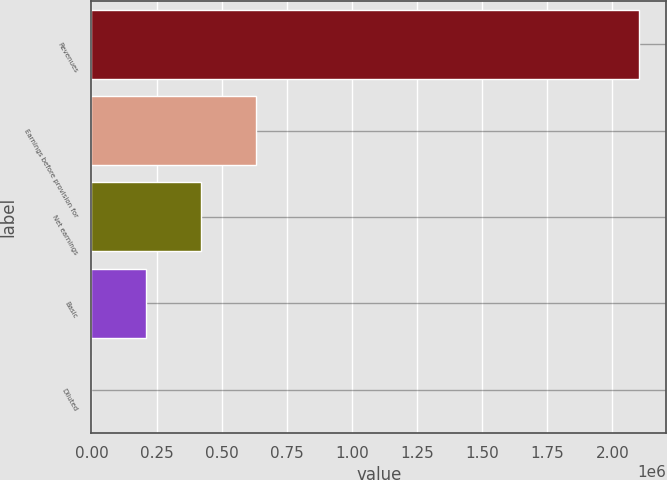<chart> <loc_0><loc_0><loc_500><loc_500><bar_chart><fcel>Revenues<fcel>Earnings before provision for<fcel>Net earnings<fcel>Basic<fcel>Diluted<nl><fcel>2.10311e+06<fcel>630933<fcel>420622<fcel>210312<fcel>1.02<nl></chart> 